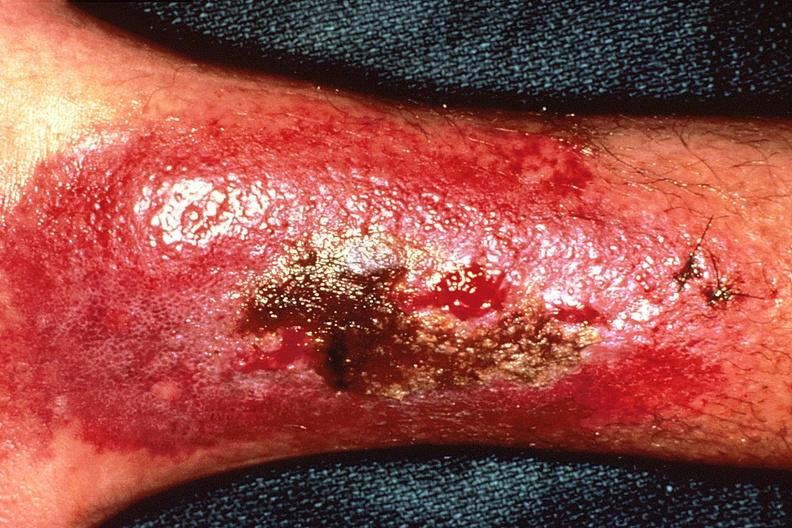what does this image show?
Answer the question using a single word or phrase. Bacterial dematitis at site of skin biopsy 